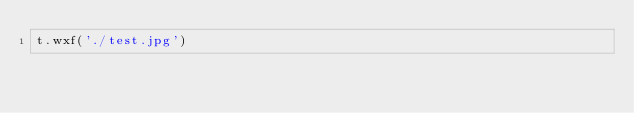<code> <loc_0><loc_0><loc_500><loc_500><_Python_>t.wxf('./test.jpg')</code> 